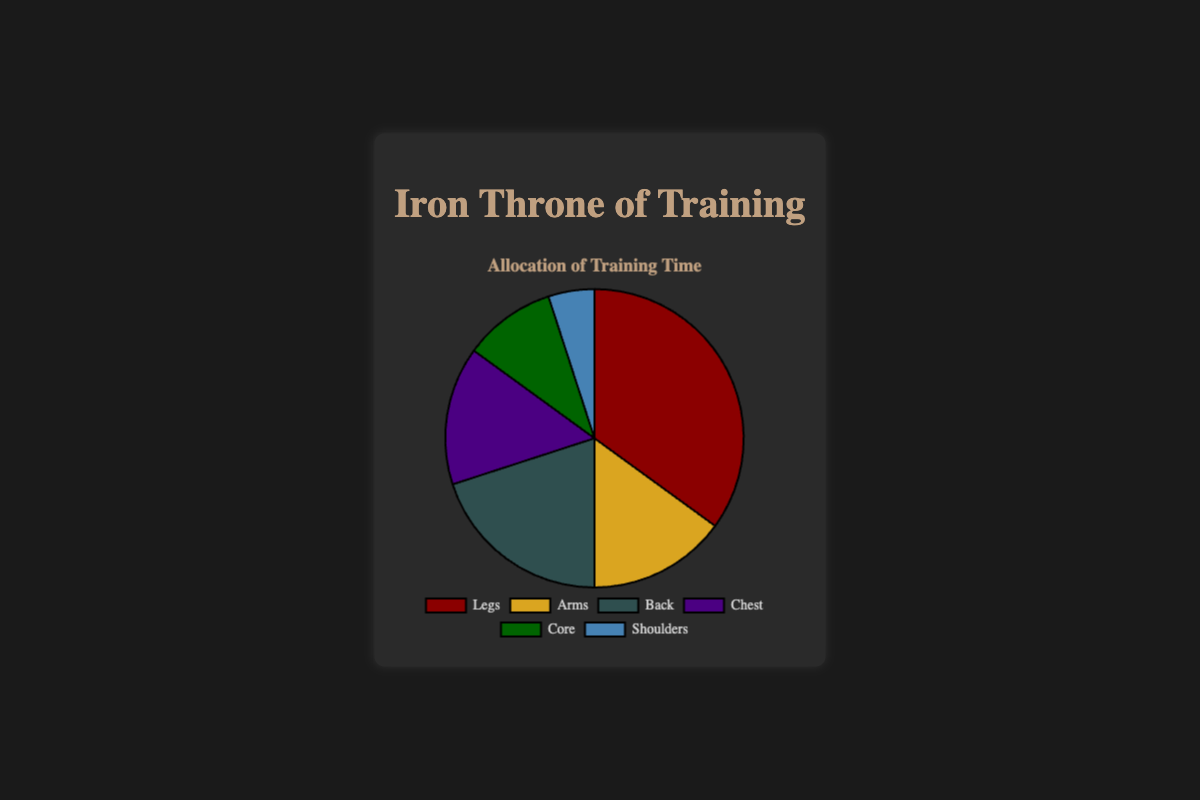What percentage of training time is dedicated to chest and back combined? Add the percentages for chest (15%) and back (20%) together: 15 + 20 = 35%
Answer: 35% Which body part receives the least amount of training time? Look for the smallest percentage value among all the segments. Shoulders have the lowest at 5%
Answer: Shoulders How much more training time is allocated to legs compared to arms? Subtract the training time percentage for arms (15%) from the legs (35%): 35 - 15 = 20%
Answer: 20% Is training time allocated to arms equal to the chest? Check the pie chart values for arms and chest, both are 15%
Answer: Yes What is the color representing the core training time? Identify the segment labeled "Core" and observe its color, which is dark green
Answer: Dark green Which two body parts combined make up exactly half of the allocated training time? Adding training time percentages for legs (35%) and back (20%) gives us 35 + 20 = 55%. Checking other combinations, legs (35%) and arms (15%) add up to 50%
Answer: Legs and Arms What is the total training time percentage allocated to the upper body parts (arms, chest, shoulders)? Adding the percentages for arms (15%), chest (15%), and shoulders (5%): 15 + 15 + 5 = 35%
Answer: 35% Among back and core, which has a higher training time allocation? Compare the values for back (20%) and core (10%) and see that back has a higher value
Answer: Back What's the difference in training time allocation between the core and shoulders? Subtract the training time percentage for shoulders (5%) from the core (10%): 10 - 5 = 5%
Answer: 5% What's the total percentage of training time dedicated to the legs and core? Summing the training times for legs (35%) and core (10%): 35 + 10 = 45%
Answer: 45% 